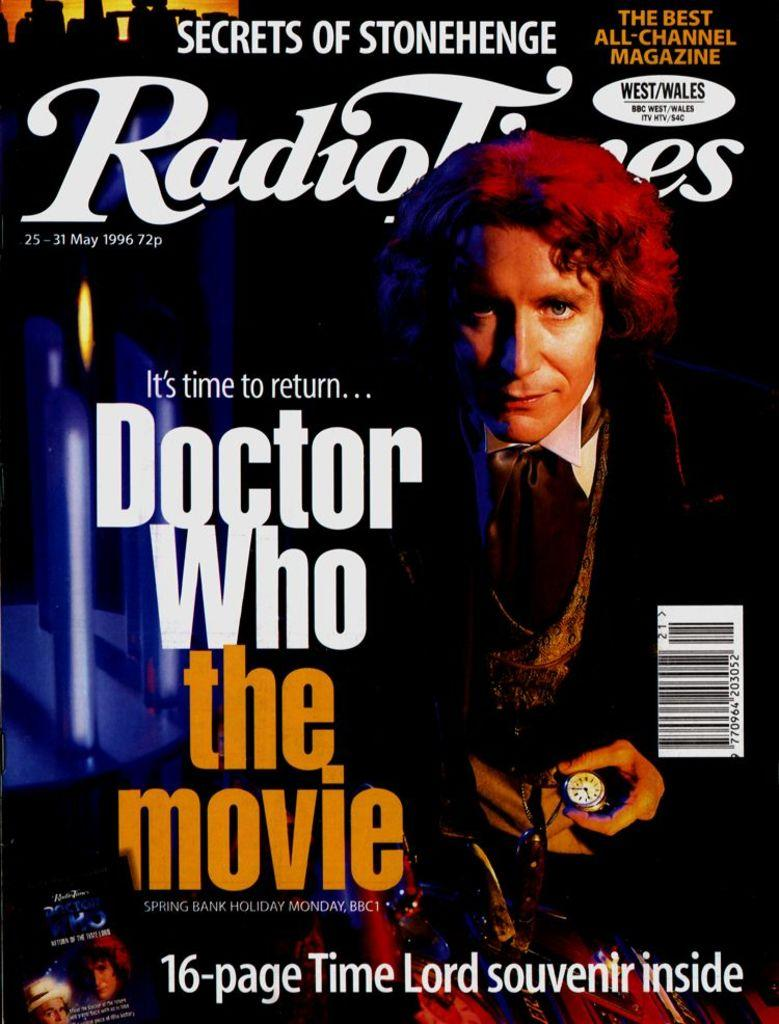<image>
Give a short and clear explanation of the subsequent image. The headline of a magazine reads DOCTOR WHO the movie. 